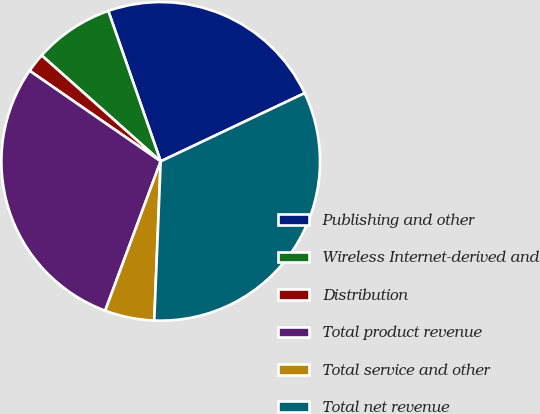Convert chart. <chart><loc_0><loc_0><loc_500><loc_500><pie_chart><fcel>Publishing and other<fcel>Wireless Internet-derived and<fcel>Distribution<fcel>Total product revenue<fcel>Total service and other<fcel>Total net revenue<nl><fcel>23.29%<fcel>8.09%<fcel>1.95%<fcel>28.96%<fcel>5.02%<fcel>32.68%<nl></chart> 